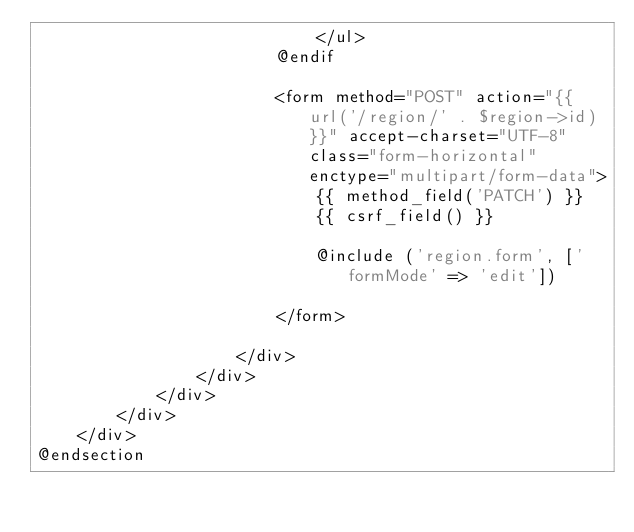Convert code to text. <code><loc_0><loc_0><loc_500><loc_500><_PHP_>                            </ul>
                        @endif

                        <form method="POST" action="{{ url('/region/' . $region->id) }}" accept-charset="UTF-8" class="form-horizontal" enctype="multipart/form-data">
                            {{ method_field('PATCH') }}
                            {{ csrf_field() }}

                            @include ('region.form', ['formMode' => 'edit'])

                        </form>

                    </div>
                </div>
            </div>
        </div>
    </div>
@endsection
</code> 